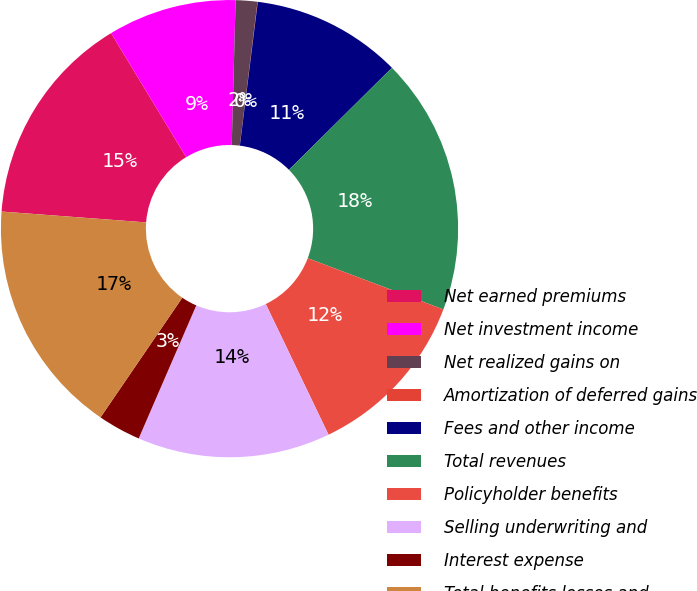Convert chart to OTSL. <chart><loc_0><loc_0><loc_500><loc_500><pie_chart><fcel>Net earned premiums<fcel>Net investment income<fcel>Net realized gains on<fcel>Amortization of deferred gains<fcel>Fees and other income<fcel>Total revenues<fcel>Policyholder benefits<fcel>Selling underwriting and<fcel>Interest expense<fcel>Total benefits losses and<nl><fcel>15.14%<fcel>9.09%<fcel>1.53%<fcel>0.02%<fcel>10.6%<fcel>18.17%<fcel>12.12%<fcel>13.63%<fcel>3.04%<fcel>16.65%<nl></chart> 